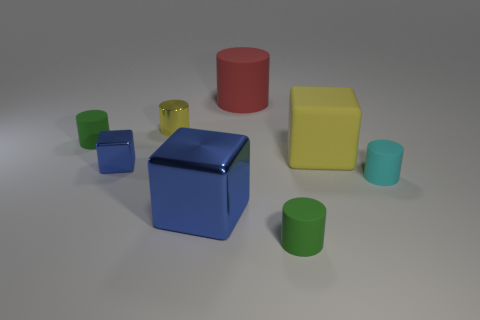Subtract 2 cylinders. How many cylinders are left? 3 Subtract all red cylinders. How many cylinders are left? 4 Subtract all brown cylinders. Subtract all yellow blocks. How many cylinders are left? 5 Add 2 tiny green matte cylinders. How many objects exist? 10 Subtract all cylinders. How many objects are left? 3 Subtract all cylinders. Subtract all small green metal spheres. How many objects are left? 3 Add 2 metal cubes. How many metal cubes are left? 4 Add 2 tiny green rubber cylinders. How many tiny green rubber cylinders exist? 4 Subtract 0 red blocks. How many objects are left? 8 